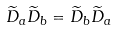<formula> <loc_0><loc_0><loc_500><loc_500>\widetilde { D } _ { a } \widetilde { D } _ { b } = \widetilde { D } _ { b } \widetilde { D } _ { a }</formula> 